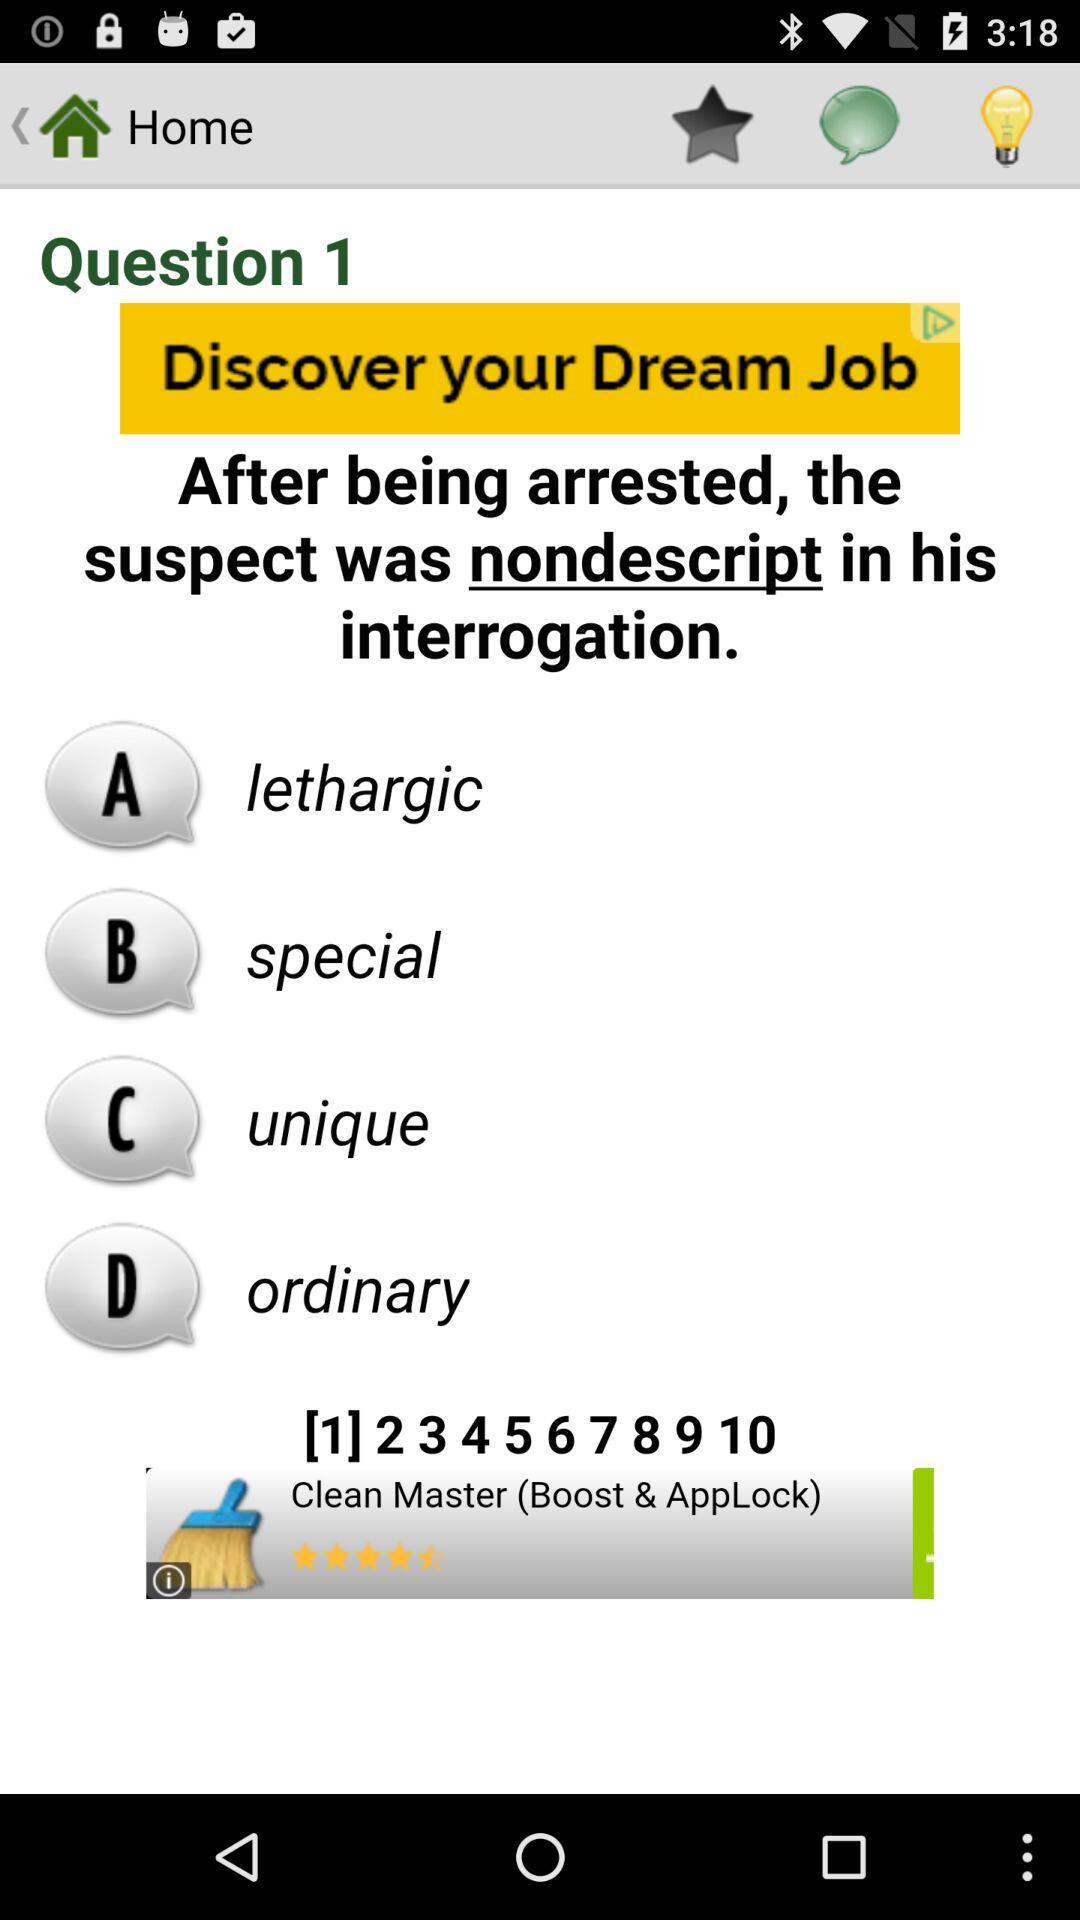At which question am i currently? You are currently on question 1. 